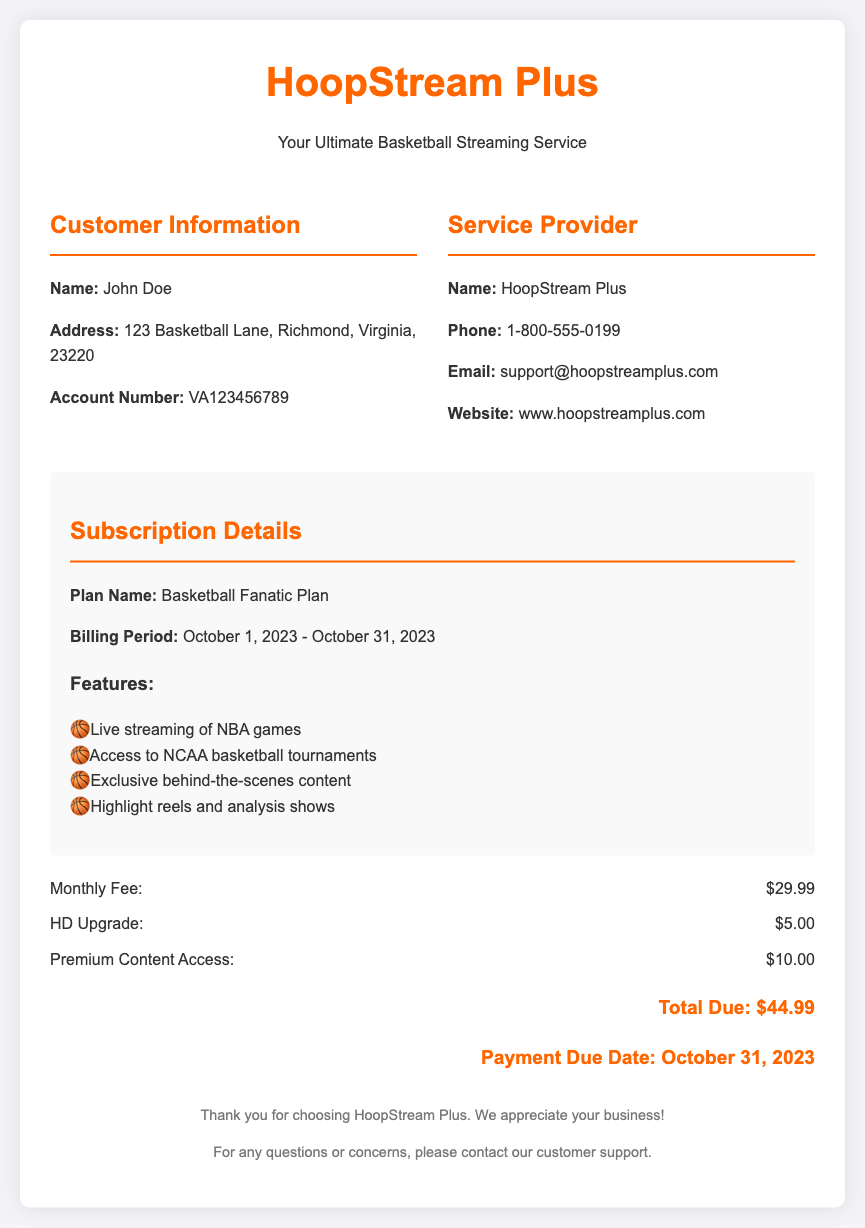What is the name of the customer? The document provides customer information which includes the name "John Doe."
Answer: John Doe What is the account number? The account number is specified in the customer information section of the document.
Answer: VA123456789 What is the billing period for this bill? The billing period is stated in the subscription details section.
Answer: October 1, 2023 - October 31, 2023 What is the total due amount? The total due amount is clearly indicated at the bottom of the bill.
Answer: $44.99 How much is the monthly fee? The monthly fee is listed in the charges section of the document.
Answer: $29.99 What features are included in the plan? The document lists several features in the subscription details section.
Answer: Live streaming of NBA games, Access to NCAA basketball tournaments, Exclusive behind-the-scenes content, Highlight reels and analysis shows What is the payment due date? The payment due date is mentioned near the total due information.
Answer: October 31, 2023 Which service provider is listed? The service provider's information is included in the bill.
Answer: HoopStream Plus What additional service has a fee of $10.00? The document details additional charges, including one that is $10.00.
Answer: Premium Content Access 